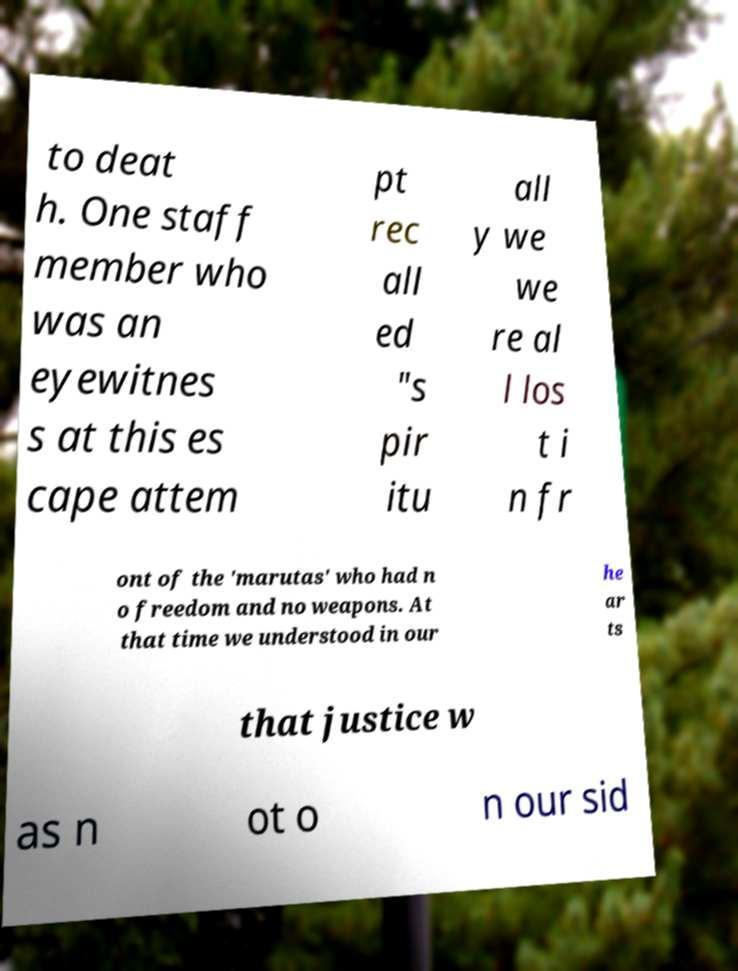Could you assist in decoding the text presented in this image and type it out clearly? to deat h. One staff member who was an eyewitnes s at this es cape attem pt rec all ed "s pir itu all y we we re al l los t i n fr ont of the 'marutas' who had n o freedom and no weapons. At that time we understood in our he ar ts that justice w as n ot o n our sid 